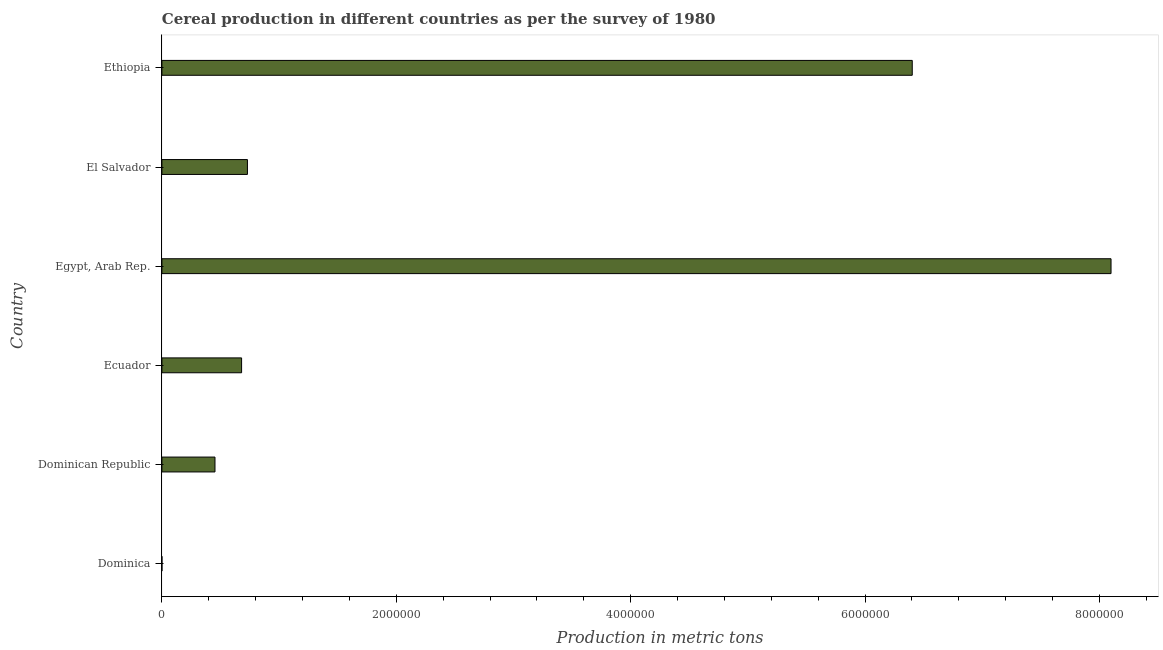Does the graph contain any zero values?
Make the answer very short. No. What is the title of the graph?
Offer a terse response. Cereal production in different countries as per the survey of 1980. What is the label or title of the X-axis?
Offer a very short reply. Production in metric tons. What is the cereal production in Ecuador?
Your response must be concise. 6.80e+05. Across all countries, what is the maximum cereal production?
Offer a terse response. 8.10e+06. Across all countries, what is the minimum cereal production?
Offer a terse response. 230. In which country was the cereal production maximum?
Keep it short and to the point. Egypt, Arab Rep. In which country was the cereal production minimum?
Your response must be concise. Dominica. What is the sum of the cereal production?
Keep it short and to the point. 1.64e+07. What is the difference between the cereal production in Ecuador and Ethiopia?
Keep it short and to the point. -5.72e+06. What is the average cereal production per country?
Make the answer very short. 2.73e+06. What is the median cereal production?
Give a very brief answer. 7.05e+05. In how many countries, is the cereal production greater than 2800000 metric tons?
Your answer should be very brief. 2. Is the cereal production in El Salvador less than that in Ethiopia?
Give a very brief answer. Yes. What is the difference between the highest and the second highest cereal production?
Keep it short and to the point. 1.70e+06. What is the difference between the highest and the lowest cereal production?
Provide a succinct answer. 8.10e+06. In how many countries, is the cereal production greater than the average cereal production taken over all countries?
Give a very brief answer. 2. How many countries are there in the graph?
Provide a succinct answer. 6. What is the difference between two consecutive major ticks on the X-axis?
Offer a very short reply. 2.00e+06. What is the Production in metric tons in Dominica?
Provide a succinct answer. 230. What is the Production in metric tons in Dominican Republic?
Your response must be concise. 4.53e+05. What is the Production in metric tons of Ecuador?
Provide a succinct answer. 6.80e+05. What is the Production in metric tons in Egypt, Arab Rep.?
Provide a short and direct response. 8.10e+06. What is the Production in metric tons of El Salvador?
Your response must be concise. 7.30e+05. What is the Production in metric tons of Ethiopia?
Your answer should be compact. 6.40e+06. What is the difference between the Production in metric tons in Dominica and Dominican Republic?
Provide a short and direct response. -4.53e+05. What is the difference between the Production in metric tons in Dominica and Ecuador?
Your response must be concise. -6.80e+05. What is the difference between the Production in metric tons in Dominica and Egypt, Arab Rep.?
Offer a terse response. -8.10e+06. What is the difference between the Production in metric tons in Dominica and El Salvador?
Provide a succinct answer. -7.30e+05. What is the difference between the Production in metric tons in Dominica and Ethiopia?
Keep it short and to the point. -6.40e+06. What is the difference between the Production in metric tons in Dominican Republic and Ecuador?
Your answer should be very brief. -2.27e+05. What is the difference between the Production in metric tons in Dominican Republic and Egypt, Arab Rep.?
Provide a succinct answer. -7.65e+06. What is the difference between the Production in metric tons in Dominican Republic and El Salvador?
Provide a short and direct response. -2.77e+05. What is the difference between the Production in metric tons in Dominican Republic and Ethiopia?
Keep it short and to the point. -5.95e+06. What is the difference between the Production in metric tons in Ecuador and Egypt, Arab Rep.?
Offer a terse response. -7.42e+06. What is the difference between the Production in metric tons in Ecuador and El Salvador?
Offer a very short reply. -5.00e+04. What is the difference between the Production in metric tons in Ecuador and Ethiopia?
Your answer should be compact. -5.72e+06. What is the difference between the Production in metric tons in Egypt, Arab Rep. and El Salvador?
Give a very brief answer. 7.37e+06. What is the difference between the Production in metric tons in Egypt, Arab Rep. and Ethiopia?
Provide a succinct answer. 1.70e+06. What is the difference between the Production in metric tons in El Salvador and Ethiopia?
Offer a very short reply. -5.67e+06. What is the ratio of the Production in metric tons in Dominica to that in Egypt, Arab Rep.?
Provide a succinct answer. 0. What is the ratio of the Production in metric tons in Dominica to that in El Salvador?
Provide a short and direct response. 0. What is the ratio of the Production in metric tons in Dominica to that in Ethiopia?
Offer a very short reply. 0. What is the ratio of the Production in metric tons in Dominican Republic to that in Ecuador?
Your answer should be very brief. 0.67. What is the ratio of the Production in metric tons in Dominican Republic to that in Egypt, Arab Rep.?
Your response must be concise. 0.06. What is the ratio of the Production in metric tons in Dominican Republic to that in El Salvador?
Provide a short and direct response. 0.62. What is the ratio of the Production in metric tons in Dominican Republic to that in Ethiopia?
Make the answer very short. 0.07. What is the ratio of the Production in metric tons in Ecuador to that in Egypt, Arab Rep.?
Offer a very short reply. 0.08. What is the ratio of the Production in metric tons in Ecuador to that in El Salvador?
Your response must be concise. 0.93. What is the ratio of the Production in metric tons in Ecuador to that in Ethiopia?
Your answer should be compact. 0.11. What is the ratio of the Production in metric tons in Egypt, Arab Rep. to that in El Salvador?
Your answer should be very brief. 11.1. What is the ratio of the Production in metric tons in Egypt, Arab Rep. to that in Ethiopia?
Offer a very short reply. 1.26. What is the ratio of the Production in metric tons in El Salvador to that in Ethiopia?
Keep it short and to the point. 0.11. 